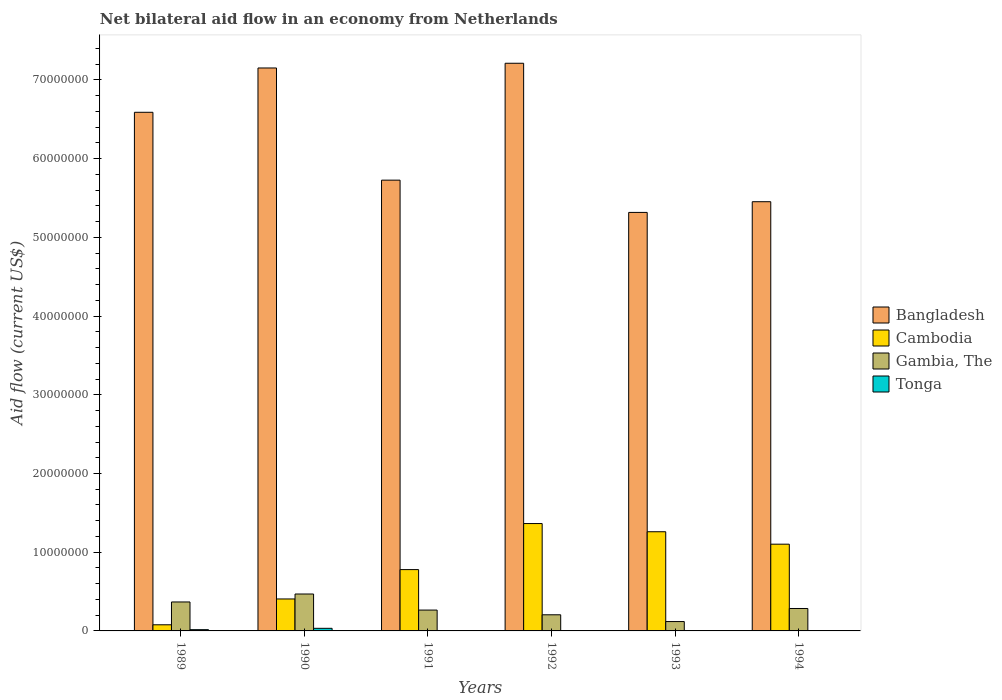How many groups of bars are there?
Offer a terse response. 6. Are the number of bars per tick equal to the number of legend labels?
Provide a succinct answer. Yes. Are the number of bars on each tick of the X-axis equal?
Ensure brevity in your answer.  Yes. How many bars are there on the 1st tick from the left?
Offer a very short reply. 4. Across all years, what is the maximum net bilateral aid flow in Bangladesh?
Ensure brevity in your answer.  7.21e+07. In which year was the net bilateral aid flow in Gambia, The maximum?
Ensure brevity in your answer.  1990. What is the total net bilateral aid flow in Cambodia in the graph?
Offer a terse response. 4.99e+07. What is the difference between the net bilateral aid flow in Bangladesh in 1989 and the net bilateral aid flow in Gambia, The in 1990?
Offer a very short reply. 6.12e+07. What is the average net bilateral aid flow in Gambia, The per year?
Provide a succinct answer. 2.85e+06. In the year 1992, what is the difference between the net bilateral aid flow in Bangladesh and net bilateral aid flow in Tonga?
Provide a short and direct response. 7.21e+07. In how many years, is the net bilateral aid flow in Tonga greater than 28000000 US$?
Keep it short and to the point. 0. What is the ratio of the net bilateral aid flow in Bangladesh in 1989 to that in 1993?
Keep it short and to the point. 1.24. Is the net bilateral aid flow in Gambia, The in 1989 less than that in 1993?
Provide a succinct answer. No. What is the difference between the highest and the second highest net bilateral aid flow in Gambia, The?
Keep it short and to the point. 1.01e+06. In how many years, is the net bilateral aid flow in Bangladesh greater than the average net bilateral aid flow in Bangladesh taken over all years?
Keep it short and to the point. 3. Is the sum of the net bilateral aid flow in Cambodia in 1992 and 1993 greater than the maximum net bilateral aid flow in Bangladesh across all years?
Your response must be concise. No. Is it the case that in every year, the sum of the net bilateral aid flow in Cambodia and net bilateral aid flow in Tonga is greater than the sum of net bilateral aid flow in Gambia, The and net bilateral aid flow in Bangladesh?
Your answer should be compact. Yes. What does the 4th bar from the left in 1989 represents?
Ensure brevity in your answer.  Tonga. What does the 2nd bar from the right in 1990 represents?
Your response must be concise. Gambia, The. How many years are there in the graph?
Give a very brief answer. 6. What is the difference between two consecutive major ticks on the Y-axis?
Offer a terse response. 1.00e+07. Where does the legend appear in the graph?
Your answer should be very brief. Center right. How many legend labels are there?
Offer a very short reply. 4. What is the title of the graph?
Provide a short and direct response. Net bilateral aid flow in an economy from Netherlands. What is the label or title of the X-axis?
Keep it short and to the point. Years. What is the Aid flow (current US$) of Bangladesh in 1989?
Give a very brief answer. 6.59e+07. What is the Aid flow (current US$) of Cambodia in 1989?
Offer a terse response. 7.80e+05. What is the Aid flow (current US$) in Gambia, The in 1989?
Your response must be concise. 3.68e+06. What is the Aid flow (current US$) of Bangladesh in 1990?
Your answer should be very brief. 7.15e+07. What is the Aid flow (current US$) of Cambodia in 1990?
Your response must be concise. 4.06e+06. What is the Aid flow (current US$) in Gambia, The in 1990?
Give a very brief answer. 4.69e+06. What is the Aid flow (current US$) of Bangladesh in 1991?
Your answer should be compact. 5.73e+07. What is the Aid flow (current US$) in Cambodia in 1991?
Offer a terse response. 7.79e+06. What is the Aid flow (current US$) in Gambia, The in 1991?
Give a very brief answer. 2.65e+06. What is the Aid flow (current US$) of Tonga in 1991?
Provide a succinct answer. 3.00e+04. What is the Aid flow (current US$) in Bangladesh in 1992?
Your answer should be compact. 7.21e+07. What is the Aid flow (current US$) in Cambodia in 1992?
Offer a very short reply. 1.36e+07. What is the Aid flow (current US$) in Gambia, The in 1992?
Make the answer very short. 2.05e+06. What is the Aid flow (current US$) of Bangladesh in 1993?
Your response must be concise. 5.32e+07. What is the Aid flow (current US$) of Cambodia in 1993?
Offer a terse response. 1.26e+07. What is the Aid flow (current US$) of Gambia, The in 1993?
Offer a very short reply. 1.19e+06. What is the Aid flow (current US$) of Tonga in 1993?
Offer a terse response. 10000. What is the Aid flow (current US$) in Bangladesh in 1994?
Ensure brevity in your answer.  5.45e+07. What is the Aid flow (current US$) in Cambodia in 1994?
Offer a terse response. 1.10e+07. What is the Aid flow (current US$) in Gambia, The in 1994?
Make the answer very short. 2.85e+06. Across all years, what is the maximum Aid flow (current US$) of Bangladesh?
Keep it short and to the point. 7.21e+07. Across all years, what is the maximum Aid flow (current US$) of Cambodia?
Give a very brief answer. 1.36e+07. Across all years, what is the maximum Aid flow (current US$) in Gambia, The?
Give a very brief answer. 4.69e+06. Across all years, what is the minimum Aid flow (current US$) in Bangladesh?
Make the answer very short. 5.32e+07. Across all years, what is the minimum Aid flow (current US$) of Cambodia?
Your answer should be very brief. 7.80e+05. Across all years, what is the minimum Aid flow (current US$) of Gambia, The?
Make the answer very short. 1.19e+06. Across all years, what is the minimum Aid flow (current US$) of Tonga?
Your answer should be compact. 10000. What is the total Aid flow (current US$) of Bangladesh in the graph?
Provide a succinct answer. 3.74e+08. What is the total Aid flow (current US$) of Cambodia in the graph?
Your answer should be very brief. 4.99e+07. What is the total Aid flow (current US$) of Gambia, The in the graph?
Provide a succinct answer. 1.71e+07. What is the difference between the Aid flow (current US$) of Bangladesh in 1989 and that in 1990?
Provide a short and direct response. -5.63e+06. What is the difference between the Aid flow (current US$) of Cambodia in 1989 and that in 1990?
Your response must be concise. -3.28e+06. What is the difference between the Aid flow (current US$) in Gambia, The in 1989 and that in 1990?
Provide a short and direct response. -1.01e+06. What is the difference between the Aid flow (current US$) in Tonga in 1989 and that in 1990?
Provide a short and direct response. -1.70e+05. What is the difference between the Aid flow (current US$) of Bangladesh in 1989 and that in 1991?
Keep it short and to the point. 8.62e+06. What is the difference between the Aid flow (current US$) of Cambodia in 1989 and that in 1991?
Give a very brief answer. -7.01e+06. What is the difference between the Aid flow (current US$) in Gambia, The in 1989 and that in 1991?
Your answer should be compact. 1.03e+06. What is the difference between the Aid flow (current US$) in Tonga in 1989 and that in 1991?
Offer a terse response. 1.30e+05. What is the difference between the Aid flow (current US$) of Bangladesh in 1989 and that in 1992?
Ensure brevity in your answer.  -6.23e+06. What is the difference between the Aid flow (current US$) of Cambodia in 1989 and that in 1992?
Your answer should be very brief. -1.29e+07. What is the difference between the Aid flow (current US$) in Gambia, The in 1989 and that in 1992?
Provide a short and direct response. 1.63e+06. What is the difference between the Aid flow (current US$) in Tonga in 1989 and that in 1992?
Offer a terse response. 1.40e+05. What is the difference between the Aid flow (current US$) of Bangladesh in 1989 and that in 1993?
Provide a short and direct response. 1.27e+07. What is the difference between the Aid flow (current US$) in Cambodia in 1989 and that in 1993?
Your answer should be very brief. -1.18e+07. What is the difference between the Aid flow (current US$) in Gambia, The in 1989 and that in 1993?
Your answer should be very brief. 2.49e+06. What is the difference between the Aid flow (current US$) in Tonga in 1989 and that in 1993?
Give a very brief answer. 1.50e+05. What is the difference between the Aid flow (current US$) of Bangladesh in 1989 and that in 1994?
Make the answer very short. 1.14e+07. What is the difference between the Aid flow (current US$) in Cambodia in 1989 and that in 1994?
Your answer should be very brief. -1.02e+07. What is the difference between the Aid flow (current US$) in Gambia, The in 1989 and that in 1994?
Provide a short and direct response. 8.30e+05. What is the difference between the Aid flow (current US$) in Bangladesh in 1990 and that in 1991?
Offer a very short reply. 1.42e+07. What is the difference between the Aid flow (current US$) in Cambodia in 1990 and that in 1991?
Offer a very short reply. -3.73e+06. What is the difference between the Aid flow (current US$) of Gambia, The in 1990 and that in 1991?
Provide a succinct answer. 2.04e+06. What is the difference between the Aid flow (current US$) in Bangladesh in 1990 and that in 1992?
Your answer should be very brief. -6.00e+05. What is the difference between the Aid flow (current US$) in Cambodia in 1990 and that in 1992?
Your response must be concise. -9.58e+06. What is the difference between the Aid flow (current US$) of Gambia, The in 1990 and that in 1992?
Give a very brief answer. 2.64e+06. What is the difference between the Aid flow (current US$) in Tonga in 1990 and that in 1992?
Make the answer very short. 3.10e+05. What is the difference between the Aid flow (current US$) of Bangladesh in 1990 and that in 1993?
Ensure brevity in your answer.  1.84e+07. What is the difference between the Aid flow (current US$) in Cambodia in 1990 and that in 1993?
Keep it short and to the point. -8.54e+06. What is the difference between the Aid flow (current US$) in Gambia, The in 1990 and that in 1993?
Your response must be concise. 3.50e+06. What is the difference between the Aid flow (current US$) in Tonga in 1990 and that in 1993?
Provide a succinct answer. 3.20e+05. What is the difference between the Aid flow (current US$) of Bangladesh in 1990 and that in 1994?
Your response must be concise. 1.70e+07. What is the difference between the Aid flow (current US$) in Cambodia in 1990 and that in 1994?
Make the answer very short. -6.96e+06. What is the difference between the Aid flow (current US$) of Gambia, The in 1990 and that in 1994?
Your response must be concise. 1.84e+06. What is the difference between the Aid flow (current US$) in Bangladesh in 1991 and that in 1992?
Ensure brevity in your answer.  -1.48e+07. What is the difference between the Aid flow (current US$) of Cambodia in 1991 and that in 1992?
Make the answer very short. -5.85e+06. What is the difference between the Aid flow (current US$) of Bangladesh in 1991 and that in 1993?
Your response must be concise. 4.10e+06. What is the difference between the Aid flow (current US$) of Cambodia in 1991 and that in 1993?
Your answer should be compact. -4.81e+06. What is the difference between the Aid flow (current US$) of Gambia, The in 1991 and that in 1993?
Provide a short and direct response. 1.46e+06. What is the difference between the Aid flow (current US$) of Tonga in 1991 and that in 1993?
Make the answer very short. 2.00e+04. What is the difference between the Aid flow (current US$) in Bangladesh in 1991 and that in 1994?
Your answer should be compact. 2.74e+06. What is the difference between the Aid flow (current US$) of Cambodia in 1991 and that in 1994?
Offer a very short reply. -3.23e+06. What is the difference between the Aid flow (current US$) in Gambia, The in 1991 and that in 1994?
Offer a terse response. -2.00e+05. What is the difference between the Aid flow (current US$) of Tonga in 1991 and that in 1994?
Ensure brevity in your answer.  -2.00e+04. What is the difference between the Aid flow (current US$) in Bangladesh in 1992 and that in 1993?
Give a very brief answer. 1.90e+07. What is the difference between the Aid flow (current US$) of Cambodia in 1992 and that in 1993?
Make the answer very short. 1.04e+06. What is the difference between the Aid flow (current US$) of Gambia, The in 1992 and that in 1993?
Provide a succinct answer. 8.60e+05. What is the difference between the Aid flow (current US$) of Bangladesh in 1992 and that in 1994?
Keep it short and to the point. 1.76e+07. What is the difference between the Aid flow (current US$) of Cambodia in 1992 and that in 1994?
Offer a very short reply. 2.62e+06. What is the difference between the Aid flow (current US$) of Gambia, The in 1992 and that in 1994?
Provide a short and direct response. -8.00e+05. What is the difference between the Aid flow (current US$) in Tonga in 1992 and that in 1994?
Keep it short and to the point. -3.00e+04. What is the difference between the Aid flow (current US$) of Bangladesh in 1993 and that in 1994?
Make the answer very short. -1.36e+06. What is the difference between the Aid flow (current US$) in Cambodia in 1993 and that in 1994?
Offer a very short reply. 1.58e+06. What is the difference between the Aid flow (current US$) of Gambia, The in 1993 and that in 1994?
Your response must be concise. -1.66e+06. What is the difference between the Aid flow (current US$) in Tonga in 1993 and that in 1994?
Your answer should be very brief. -4.00e+04. What is the difference between the Aid flow (current US$) of Bangladesh in 1989 and the Aid flow (current US$) of Cambodia in 1990?
Your answer should be compact. 6.18e+07. What is the difference between the Aid flow (current US$) in Bangladesh in 1989 and the Aid flow (current US$) in Gambia, The in 1990?
Offer a very short reply. 6.12e+07. What is the difference between the Aid flow (current US$) in Bangladesh in 1989 and the Aid flow (current US$) in Tonga in 1990?
Your answer should be compact. 6.56e+07. What is the difference between the Aid flow (current US$) in Cambodia in 1989 and the Aid flow (current US$) in Gambia, The in 1990?
Provide a succinct answer. -3.91e+06. What is the difference between the Aid flow (current US$) in Gambia, The in 1989 and the Aid flow (current US$) in Tonga in 1990?
Keep it short and to the point. 3.35e+06. What is the difference between the Aid flow (current US$) in Bangladesh in 1989 and the Aid flow (current US$) in Cambodia in 1991?
Ensure brevity in your answer.  5.81e+07. What is the difference between the Aid flow (current US$) in Bangladesh in 1989 and the Aid flow (current US$) in Gambia, The in 1991?
Your answer should be compact. 6.32e+07. What is the difference between the Aid flow (current US$) of Bangladesh in 1989 and the Aid flow (current US$) of Tonga in 1991?
Offer a terse response. 6.59e+07. What is the difference between the Aid flow (current US$) of Cambodia in 1989 and the Aid flow (current US$) of Gambia, The in 1991?
Provide a succinct answer. -1.87e+06. What is the difference between the Aid flow (current US$) in Cambodia in 1989 and the Aid flow (current US$) in Tonga in 1991?
Offer a very short reply. 7.50e+05. What is the difference between the Aid flow (current US$) of Gambia, The in 1989 and the Aid flow (current US$) of Tonga in 1991?
Ensure brevity in your answer.  3.65e+06. What is the difference between the Aid flow (current US$) of Bangladesh in 1989 and the Aid flow (current US$) of Cambodia in 1992?
Offer a terse response. 5.22e+07. What is the difference between the Aid flow (current US$) in Bangladesh in 1989 and the Aid flow (current US$) in Gambia, The in 1992?
Keep it short and to the point. 6.38e+07. What is the difference between the Aid flow (current US$) in Bangladesh in 1989 and the Aid flow (current US$) in Tonga in 1992?
Provide a succinct answer. 6.59e+07. What is the difference between the Aid flow (current US$) in Cambodia in 1989 and the Aid flow (current US$) in Gambia, The in 1992?
Give a very brief answer. -1.27e+06. What is the difference between the Aid flow (current US$) in Cambodia in 1989 and the Aid flow (current US$) in Tonga in 1992?
Offer a very short reply. 7.60e+05. What is the difference between the Aid flow (current US$) of Gambia, The in 1989 and the Aid flow (current US$) of Tonga in 1992?
Ensure brevity in your answer.  3.66e+06. What is the difference between the Aid flow (current US$) in Bangladesh in 1989 and the Aid flow (current US$) in Cambodia in 1993?
Make the answer very short. 5.33e+07. What is the difference between the Aid flow (current US$) of Bangladesh in 1989 and the Aid flow (current US$) of Gambia, The in 1993?
Your answer should be compact. 6.47e+07. What is the difference between the Aid flow (current US$) of Bangladesh in 1989 and the Aid flow (current US$) of Tonga in 1993?
Make the answer very short. 6.59e+07. What is the difference between the Aid flow (current US$) in Cambodia in 1989 and the Aid flow (current US$) in Gambia, The in 1993?
Make the answer very short. -4.10e+05. What is the difference between the Aid flow (current US$) in Cambodia in 1989 and the Aid flow (current US$) in Tonga in 1993?
Give a very brief answer. 7.70e+05. What is the difference between the Aid flow (current US$) of Gambia, The in 1989 and the Aid flow (current US$) of Tonga in 1993?
Your answer should be compact. 3.67e+06. What is the difference between the Aid flow (current US$) in Bangladesh in 1989 and the Aid flow (current US$) in Cambodia in 1994?
Your answer should be compact. 5.49e+07. What is the difference between the Aid flow (current US$) of Bangladesh in 1989 and the Aid flow (current US$) of Gambia, The in 1994?
Your response must be concise. 6.30e+07. What is the difference between the Aid flow (current US$) of Bangladesh in 1989 and the Aid flow (current US$) of Tonga in 1994?
Keep it short and to the point. 6.58e+07. What is the difference between the Aid flow (current US$) in Cambodia in 1989 and the Aid flow (current US$) in Gambia, The in 1994?
Your answer should be compact. -2.07e+06. What is the difference between the Aid flow (current US$) in Cambodia in 1989 and the Aid flow (current US$) in Tonga in 1994?
Offer a very short reply. 7.30e+05. What is the difference between the Aid flow (current US$) in Gambia, The in 1989 and the Aid flow (current US$) in Tonga in 1994?
Provide a short and direct response. 3.63e+06. What is the difference between the Aid flow (current US$) of Bangladesh in 1990 and the Aid flow (current US$) of Cambodia in 1991?
Your answer should be compact. 6.37e+07. What is the difference between the Aid flow (current US$) in Bangladesh in 1990 and the Aid flow (current US$) in Gambia, The in 1991?
Offer a terse response. 6.89e+07. What is the difference between the Aid flow (current US$) of Bangladesh in 1990 and the Aid flow (current US$) of Tonga in 1991?
Offer a terse response. 7.15e+07. What is the difference between the Aid flow (current US$) of Cambodia in 1990 and the Aid flow (current US$) of Gambia, The in 1991?
Ensure brevity in your answer.  1.41e+06. What is the difference between the Aid flow (current US$) of Cambodia in 1990 and the Aid flow (current US$) of Tonga in 1991?
Make the answer very short. 4.03e+06. What is the difference between the Aid flow (current US$) of Gambia, The in 1990 and the Aid flow (current US$) of Tonga in 1991?
Your answer should be compact. 4.66e+06. What is the difference between the Aid flow (current US$) in Bangladesh in 1990 and the Aid flow (current US$) in Cambodia in 1992?
Your answer should be very brief. 5.79e+07. What is the difference between the Aid flow (current US$) of Bangladesh in 1990 and the Aid flow (current US$) of Gambia, The in 1992?
Your answer should be very brief. 6.95e+07. What is the difference between the Aid flow (current US$) in Bangladesh in 1990 and the Aid flow (current US$) in Tonga in 1992?
Offer a very short reply. 7.15e+07. What is the difference between the Aid flow (current US$) in Cambodia in 1990 and the Aid flow (current US$) in Gambia, The in 1992?
Your answer should be compact. 2.01e+06. What is the difference between the Aid flow (current US$) in Cambodia in 1990 and the Aid flow (current US$) in Tonga in 1992?
Ensure brevity in your answer.  4.04e+06. What is the difference between the Aid flow (current US$) of Gambia, The in 1990 and the Aid flow (current US$) of Tonga in 1992?
Offer a terse response. 4.67e+06. What is the difference between the Aid flow (current US$) in Bangladesh in 1990 and the Aid flow (current US$) in Cambodia in 1993?
Your response must be concise. 5.89e+07. What is the difference between the Aid flow (current US$) of Bangladesh in 1990 and the Aid flow (current US$) of Gambia, The in 1993?
Your answer should be compact. 7.03e+07. What is the difference between the Aid flow (current US$) of Bangladesh in 1990 and the Aid flow (current US$) of Tonga in 1993?
Make the answer very short. 7.15e+07. What is the difference between the Aid flow (current US$) of Cambodia in 1990 and the Aid flow (current US$) of Gambia, The in 1993?
Offer a terse response. 2.87e+06. What is the difference between the Aid flow (current US$) in Cambodia in 1990 and the Aid flow (current US$) in Tonga in 1993?
Ensure brevity in your answer.  4.05e+06. What is the difference between the Aid flow (current US$) of Gambia, The in 1990 and the Aid flow (current US$) of Tonga in 1993?
Your answer should be very brief. 4.68e+06. What is the difference between the Aid flow (current US$) of Bangladesh in 1990 and the Aid flow (current US$) of Cambodia in 1994?
Keep it short and to the point. 6.05e+07. What is the difference between the Aid flow (current US$) in Bangladesh in 1990 and the Aid flow (current US$) in Gambia, The in 1994?
Provide a succinct answer. 6.87e+07. What is the difference between the Aid flow (current US$) in Bangladesh in 1990 and the Aid flow (current US$) in Tonga in 1994?
Provide a short and direct response. 7.15e+07. What is the difference between the Aid flow (current US$) of Cambodia in 1990 and the Aid flow (current US$) of Gambia, The in 1994?
Provide a short and direct response. 1.21e+06. What is the difference between the Aid flow (current US$) of Cambodia in 1990 and the Aid flow (current US$) of Tonga in 1994?
Make the answer very short. 4.01e+06. What is the difference between the Aid flow (current US$) in Gambia, The in 1990 and the Aid flow (current US$) in Tonga in 1994?
Give a very brief answer. 4.64e+06. What is the difference between the Aid flow (current US$) of Bangladesh in 1991 and the Aid flow (current US$) of Cambodia in 1992?
Offer a terse response. 4.36e+07. What is the difference between the Aid flow (current US$) in Bangladesh in 1991 and the Aid flow (current US$) in Gambia, The in 1992?
Offer a very short reply. 5.52e+07. What is the difference between the Aid flow (current US$) of Bangladesh in 1991 and the Aid flow (current US$) of Tonga in 1992?
Your answer should be very brief. 5.72e+07. What is the difference between the Aid flow (current US$) in Cambodia in 1991 and the Aid flow (current US$) in Gambia, The in 1992?
Offer a very short reply. 5.74e+06. What is the difference between the Aid flow (current US$) of Cambodia in 1991 and the Aid flow (current US$) of Tonga in 1992?
Provide a succinct answer. 7.77e+06. What is the difference between the Aid flow (current US$) of Gambia, The in 1991 and the Aid flow (current US$) of Tonga in 1992?
Your answer should be very brief. 2.63e+06. What is the difference between the Aid flow (current US$) in Bangladesh in 1991 and the Aid flow (current US$) in Cambodia in 1993?
Your answer should be compact. 4.47e+07. What is the difference between the Aid flow (current US$) of Bangladesh in 1991 and the Aid flow (current US$) of Gambia, The in 1993?
Your response must be concise. 5.61e+07. What is the difference between the Aid flow (current US$) in Bangladesh in 1991 and the Aid flow (current US$) in Tonga in 1993?
Provide a short and direct response. 5.73e+07. What is the difference between the Aid flow (current US$) in Cambodia in 1991 and the Aid flow (current US$) in Gambia, The in 1993?
Give a very brief answer. 6.60e+06. What is the difference between the Aid flow (current US$) in Cambodia in 1991 and the Aid flow (current US$) in Tonga in 1993?
Your response must be concise. 7.78e+06. What is the difference between the Aid flow (current US$) of Gambia, The in 1991 and the Aid flow (current US$) of Tonga in 1993?
Give a very brief answer. 2.64e+06. What is the difference between the Aid flow (current US$) of Bangladesh in 1991 and the Aid flow (current US$) of Cambodia in 1994?
Give a very brief answer. 4.62e+07. What is the difference between the Aid flow (current US$) of Bangladesh in 1991 and the Aid flow (current US$) of Gambia, The in 1994?
Your answer should be compact. 5.44e+07. What is the difference between the Aid flow (current US$) of Bangladesh in 1991 and the Aid flow (current US$) of Tonga in 1994?
Give a very brief answer. 5.72e+07. What is the difference between the Aid flow (current US$) of Cambodia in 1991 and the Aid flow (current US$) of Gambia, The in 1994?
Make the answer very short. 4.94e+06. What is the difference between the Aid flow (current US$) of Cambodia in 1991 and the Aid flow (current US$) of Tonga in 1994?
Offer a very short reply. 7.74e+06. What is the difference between the Aid flow (current US$) of Gambia, The in 1991 and the Aid flow (current US$) of Tonga in 1994?
Provide a short and direct response. 2.60e+06. What is the difference between the Aid flow (current US$) of Bangladesh in 1992 and the Aid flow (current US$) of Cambodia in 1993?
Offer a terse response. 5.95e+07. What is the difference between the Aid flow (current US$) of Bangladesh in 1992 and the Aid flow (current US$) of Gambia, The in 1993?
Keep it short and to the point. 7.09e+07. What is the difference between the Aid flow (current US$) in Bangladesh in 1992 and the Aid flow (current US$) in Tonga in 1993?
Ensure brevity in your answer.  7.21e+07. What is the difference between the Aid flow (current US$) of Cambodia in 1992 and the Aid flow (current US$) of Gambia, The in 1993?
Your response must be concise. 1.24e+07. What is the difference between the Aid flow (current US$) in Cambodia in 1992 and the Aid flow (current US$) in Tonga in 1993?
Offer a terse response. 1.36e+07. What is the difference between the Aid flow (current US$) of Gambia, The in 1992 and the Aid flow (current US$) of Tonga in 1993?
Keep it short and to the point. 2.04e+06. What is the difference between the Aid flow (current US$) in Bangladesh in 1992 and the Aid flow (current US$) in Cambodia in 1994?
Your answer should be compact. 6.11e+07. What is the difference between the Aid flow (current US$) in Bangladesh in 1992 and the Aid flow (current US$) in Gambia, The in 1994?
Give a very brief answer. 6.93e+07. What is the difference between the Aid flow (current US$) of Bangladesh in 1992 and the Aid flow (current US$) of Tonga in 1994?
Give a very brief answer. 7.21e+07. What is the difference between the Aid flow (current US$) of Cambodia in 1992 and the Aid flow (current US$) of Gambia, The in 1994?
Provide a succinct answer. 1.08e+07. What is the difference between the Aid flow (current US$) of Cambodia in 1992 and the Aid flow (current US$) of Tonga in 1994?
Give a very brief answer. 1.36e+07. What is the difference between the Aid flow (current US$) of Bangladesh in 1993 and the Aid flow (current US$) of Cambodia in 1994?
Provide a succinct answer. 4.22e+07. What is the difference between the Aid flow (current US$) in Bangladesh in 1993 and the Aid flow (current US$) in Gambia, The in 1994?
Make the answer very short. 5.03e+07. What is the difference between the Aid flow (current US$) of Bangladesh in 1993 and the Aid flow (current US$) of Tonga in 1994?
Your answer should be very brief. 5.31e+07. What is the difference between the Aid flow (current US$) in Cambodia in 1993 and the Aid flow (current US$) in Gambia, The in 1994?
Your answer should be compact. 9.75e+06. What is the difference between the Aid flow (current US$) in Cambodia in 1993 and the Aid flow (current US$) in Tonga in 1994?
Make the answer very short. 1.26e+07. What is the difference between the Aid flow (current US$) in Gambia, The in 1993 and the Aid flow (current US$) in Tonga in 1994?
Ensure brevity in your answer.  1.14e+06. What is the average Aid flow (current US$) in Bangladesh per year?
Your answer should be compact. 6.24e+07. What is the average Aid flow (current US$) in Cambodia per year?
Give a very brief answer. 8.32e+06. What is the average Aid flow (current US$) of Gambia, The per year?
Ensure brevity in your answer.  2.85e+06. What is the average Aid flow (current US$) in Tonga per year?
Offer a terse response. 1.00e+05. In the year 1989, what is the difference between the Aid flow (current US$) of Bangladesh and Aid flow (current US$) of Cambodia?
Your response must be concise. 6.51e+07. In the year 1989, what is the difference between the Aid flow (current US$) of Bangladesh and Aid flow (current US$) of Gambia, The?
Give a very brief answer. 6.22e+07. In the year 1989, what is the difference between the Aid flow (current US$) of Bangladesh and Aid flow (current US$) of Tonga?
Your answer should be very brief. 6.57e+07. In the year 1989, what is the difference between the Aid flow (current US$) in Cambodia and Aid flow (current US$) in Gambia, The?
Your answer should be compact. -2.90e+06. In the year 1989, what is the difference between the Aid flow (current US$) in Cambodia and Aid flow (current US$) in Tonga?
Keep it short and to the point. 6.20e+05. In the year 1989, what is the difference between the Aid flow (current US$) of Gambia, The and Aid flow (current US$) of Tonga?
Provide a succinct answer. 3.52e+06. In the year 1990, what is the difference between the Aid flow (current US$) of Bangladesh and Aid flow (current US$) of Cambodia?
Your answer should be compact. 6.75e+07. In the year 1990, what is the difference between the Aid flow (current US$) in Bangladesh and Aid flow (current US$) in Gambia, The?
Provide a succinct answer. 6.68e+07. In the year 1990, what is the difference between the Aid flow (current US$) in Bangladesh and Aid flow (current US$) in Tonga?
Provide a succinct answer. 7.12e+07. In the year 1990, what is the difference between the Aid flow (current US$) in Cambodia and Aid flow (current US$) in Gambia, The?
Offer a very short reply. -6.30e+05. In the year 1990, what is the difference between the Aid flow (current US$) of Cambodia and Aid flow (current US$) of Tonga?
Offer a very short reply. 3.73e+06. In the year 1990, what is the difference between the Aid flow (current US$) of Gambia, The and Aid flow (current US$) of Tonga?
Your answer should be compact. 4.36e+06. In the year 1991, what is the difference between the Aid flow (current US$) in Bangladesh and Aid flow (current US$) in Cambodia?
Keep it short and to the point. 4.95e+07. In the year 1991, what is the difference between the Aid flow (current US$) of Bangladesh and Aid flow (current US$) of Gambia, The?
Provide a short and direct response. 5.46e+07. In the year 1991, what is the difference between the Aid flow (current US$) of Bangladesh and Aid flow (current US$) of Tonga?
Ensure brevity in your answer.  5.72e+07. In the year 1991, what is the difference between the Aid flow (current US$) of Cambodia and Aid flow (current US$) of Gambia, The?
Give a very brief answer. 5.14e+06. In the year 1991, what is the difference between the Aid flow (current US$) in Cambodia and Aid flow (current US$) in Tonga?
Make the answer very short. 7.76e+06. In the year 1991, what is the difference between the Aid flow (current US$) in Gambia, The and Aid flow (current US$) in Tonga?
Keep it short and to the point. 2.62e+06. In the year 1992, what is the difference between the Aid flow (current US$) in Bangladesh and Aid flow (current US$) in Cambodia?
Provide a succinct answer. 5.85e+07. In the year 1992, what is the difference between the Aid flow (current US$) in Bangladesh and Aid flow (current US$) in Gambia, The?
Make the answer very short. 7.01e+07. In the year 1992, what is the difference between the Aid flow (current US$) of Bangladesh and Aid flow (current US$) of Tonga?
Your answer should be very brief. 7.21e+07. In the year 1992, what is the difference between the Aid flow (current US$) of Cambodia and Aid flow (current US$) of Gambia, The?
Your response must be concise. 1.16e+07. In the year 1992, what is the difference between the Aid flow (current US$) in Cambodia and Aid flow (current US$) in Tonga?
Offer a very short reply. 1.36e+07. In the year 1992, what is the difference between the Aid flow (current US$) in Gambia, The and Aid flow (current US$) in Tonga?
Your answer should be compact. 2.03e+06. In the year 1993, what is the difference between the Aid flow (current US$) of Bangladesh and Aid flow (current US$) of Cambodia?
Offer a very short reply. 4.06e+07. In the year 1993, what is the difference between the Aid flow (current US$) of Bangladesh and Aid flow (current US$) of Gambia, The?
Make the answer very short. 5.20e+07. In the year 1993, what is the difference between the Aid flow (current US$) in Bangladesh and Aid flow (current US$) in Tonga?
Provide a short and direct response. 5.32e+07. In the year 1993, what is the difference between the Aid flow (current US$) in Cambodia and Aid flow (current US$) in Gambia, The?
Your answer should be very brief. 1.14e+07. In the year 1993, what is the difference between the Aid flow (current US$) of Cambodia and Aid flow (current US$) of Tonga?
Ensure brevity in your answer.  1.26e+07. In the year 1993, what is the difference between the Aid flow (current US$) in Gambia, The and Aid flow (current US$) in Tonga?
Give a very brief answer. 1.18e+06. In the year 1994, what is the difference between the Aid flow (current US$) of Bangladesh and Aid flow (current US$) of Cambodia?
Your response must be concise. 4.35e+07. In the year 1994, what is the difference between the Aid flow (current US$) in Bangladesh and Aid flow (current US$) in Gambia, The?
Make the answer very short. 5.17e+07. In the year 1994, what is the difference between the Aid flow (current US$) of Bangladesh and Aid flow (current US$) of Tonga?
Ensure brevity in your answer.  5.45e+07. In the year 1994, what is the difference between the Aid flow (current US$) in Cambodia and Aid flow (current US$) in Gambia, The?
Offer a very short reply. 8.17e+06. In the year 1994, what is the difference between the Aid flow (current US$) in Cambodia and Aid flow (current US$) in Tonga?
Provide a short and direct response. 1.10e+07. In the year 1994, what is the difference between the Aid flow (current US$) in Gambia, The and Aid flow (current US$) in Tonga?
Your response must be concise. 2.80e+06. What is the ratio of the Aid flow (current US$) in Bangladesh in 1989 to that in 1990?
Make the answer very short. 0.92. What is the ratio of the Aid flow (current US$) in Cambodia in 1989 to that in 1990?
Provide a succinct answer. 0.19. What is the ratio of the Aid flow (current US$) in Gambia, The in 1989 to that in 1990?
Provide a succinct answer. 0.78. What is the ratio of the Aid flow (current US$) in Tonga in 1989 to that in 1990?
Make the answer very short. 0.48. What is the ratio of the Aid flow (current US$) in Bangladesh in 1989 to that in 1991?
Make the answer very short. 1.15. What is the ratio of the Aid flow (current US$) in Cambodia in 1989 to that in 1991?
Ensure brevity in your answer.  0.1. What is the ratio of the Aid flow (current US$) of Gambia, The in 1989 to that in 1991?
Make the answer very short. 1.39. What is the ratio of the Aid flow (current US$) in Tonga in 1989 to that in 1991?
Make the answer very short. 5.33. What is the ratio of the Aid flow (current US$) of Bangladesh in 1989 to that in 1992?
Ensure brevity in your answer.  0.91. What is the ratio of the Aid flow (current US$) of Cambodia in 1989 to that in 1992?
Keep it short and to the point. 0.06. What is the ratio of the Aid flow (current US$) in Gambia, The in 1989 to that in 1992?
Offer a very short reply. 1.8. What is the ratio of the Aid flow (current US$) of Tonga in 1989 to that in 1992?
Give a very brief answer. 8. What is the ratio of the Aid flow (current US$) of Bangladesh in 1989 to that in 1993?
Your answer should be very brief. 1.24. What is the ratio of the Aid flow (current US$) in Cambodia in 1989 to that in 1993?
Ensure brevity in your answer.  0.06. What is the ratio of the Aid flow (current US$) of Gambia, The in 1989 to that in 1993?
Provide a short and direct response. 3.09. What is the ratio of the Aid flow (current US$) in Tonga in 1989 to that in 1993?
Your response must be concise. 16. What is the ratio of the Aid flow (current US$) in Bangladesh in 1989 to that in 1994?
Give a very brief answer. 1.21. What is the ratio of the Aid flow (current US$) of Cambodia in 1989 to that in 1994?
Ensure brevity in your answer.  0.07. What is the ratio of the Aid flow (current US$) in Gambia, The in 1989 to that in 1994?
Ensure brevity in your answer.  1.29. What is the ratio of the Aid flow (current US$) in Bangladesh in 1990 to that in 1991?
Provide a short and direct response. 1.25. What is the ratio of the Aid flow (current US$) of Cambodia in 1990 to that in 1991?
Your answer should be compact. 0.52. What is the ratio of the Aid flow (current US$) in Gambia, The in 1990 to that in 1991?
Offer a terse response. 1.77. What is the ratio of the Aid flow (current US$) in Cambodia in 1990 to that in 1992?
Give a very brief answer. 0.3. What is the ratio of the Aid flow (current US$) in Gambia, The in 1990 to that in 1992?
Offer a terse response. 2.29. What is the ratio of the Aid flow (current US$) of Bangladesh in 1990 to that in 1993?
Offer a terse response. 1.35. What is the ratio of the Aid flow (current US$) in Cambodia in 1990 to that in 1993?
Your answer should be very brief. 0.32. What is the ratio of the Aid flow (current US$) of Gambia, The in 1990 to that in 1993?
Keep it short and to the point. 3.94. What is the ratio of the Aid flow (current US$) of Bangladesh in 1990 to that in 1994?
Provide a short and direct response. 1.31. What is the ratio of the Aid flow (current US$) in Cambodia in 1990 to that in 1994?
Offer a terse response. 0.37. What is the ratio of the Aid flow (current US$) in Gambia, The in 1990 to that in 1994?
Make the answer very short. 1.65. What is the ratio of the Aid flow (current US$) of Tonga in 1990 to that in 1994?
Offer a very short reply. 6.6. What is the ratio of the Aid flow (current US$) in Bangladesh in 1991 to that in 1992?
Provide a succinct answer. 0.79. What is the ratio of the Aid flow (current US$) of Cambodia in 1991 to that in 1992?
Your answer should be compact. 0.57. What is the ratio of the Aid flow (current US$) in Gambia, The in 1991 to that in 1992?
Your response must be concise. 1.29. What is the ratio of the Aid flow (current US$) of Bangladesh in 1991 to that in 1993?
Provide a short and direct response. 1.08. What is the ratio of the Aid flow (current US$) of Cambodia in 1991 to that in 1993?
Offer a very short reply. 0.62. What is the ratio of the Aid flow (current US$) of Gambia, The in 1991 to that in 1993?
Your response must be concise. 2.23. What is the ratio of the Aid flow (current US$) in Bangladesh in 1991 to that in 1994?
Your answer should be very brief. 1.05. What is the ratio of the Aid flow (current US$) of Cambodia in 1991 to that in 1994?
Keep it short and to the point. 0.71. What is the ratio of the Aid flow (current US$) in Gambia, The in 1991 to that in 1994?
Give a very brief answer. 0.93. What is the ratio of the Aid flow (current US$) of Bangladesh in 1992 to that in 1993?
Give a very brief answer. 1.36. What is the ratio of the Aid flow (current US$) of Cambodia in 1992 to that in 1993?
Your answer should be compact. 1.08. What is the ratio of the Aid flow (current US$) of Gambia, The in 1992 to that in 1993?
Give a very brief answer. 1.72. What is the ratio of the Aid flow (current US$) of Tonga in 1992 to that in 1993?
Your answer should be very brief. 2. What is the ratio of the Aid flow (current US$) in Bangladesh in 1992 to that in 1994?
Make the answer very short. 1.32. What is the ratio of the Aid flow (current US$) in Cambodia in 1992 to that in 1994?
Provide a succinct answer. 1.24. What is the ratio of the Aid flow (current US$) of Gambia, The in 1992 to that in 1994?
Provide a succinct answer. 0.72. What is the ratio of the Aid flow (current US$) in Bangladesh in 1993 to that in 1994?
Give a very brief answer. 0.98. What is the ratio of the Aid flow (current US$) in Cambodia in 1993 to that in 1994?
Make the answer very short. 1.14. What is the ratio of the Aid flow (current US$) of Gambia, The in 1993 to that in 1994?
Your response must be concise. 0.42. What is the difference between the highest and the second highest Aid flow (current US$) of Bangladesh?
Ensure brevity in your answer.  6.00e+05. What is the difference between the highest and the second highest Aid flow (current US$) of Cambodia?
Give a very brief answer. 1.04e+06. What is the difference between the highest and the second highest Aid flow (current US$) of Gambia, The?
Ensure brevity in your answer.  1.01e+06. What is the difference between the highest and the second highest Aid flow (current US$) in Tonga?
Keep it short and to the point. 1.70e+05. What is the difference between the highest and the lowest Aid flow (current US$) in Bangladesh?
Your answer should be compact. 1.90e+07. What is the difference between the highest and the lowest Aid flow (current US$) in Cambodia?
Provide a short and direct response. 1.29e+07. What is the difference between the highest and the lowest Aid flow (current US$) of Gambia, The?
Make the answer very short. 3.50e+06. What is the difference between the highest and the lowest Aid flow (current US$) of Tonga?
Make the answer very short. 3.20e+05. 